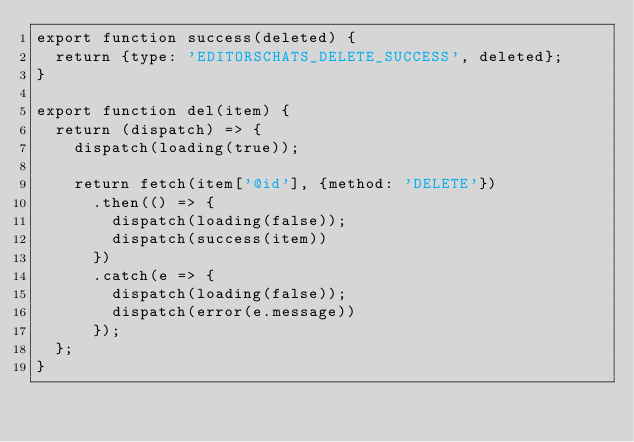<code> <loc_0><loc_0><loc_500><loc_500><_JavaScript_>export function success(deleted) {
  return {type: 'EDITORSCHATS_DELETE_SUCCESS', deleted};
}

export function del(item) {
  return (dispatch) => {
    dispatch(loading(true));

    return fetch(item['@id'], {method: 'DELETE'})
      .then(() => {
        dispatch(loading(false));
        dispatch(success(item))
      })
      .catch(e => {
        dispatch(loading(false));
        dispatch(error(e.message))
      });
  };
}
</code> 